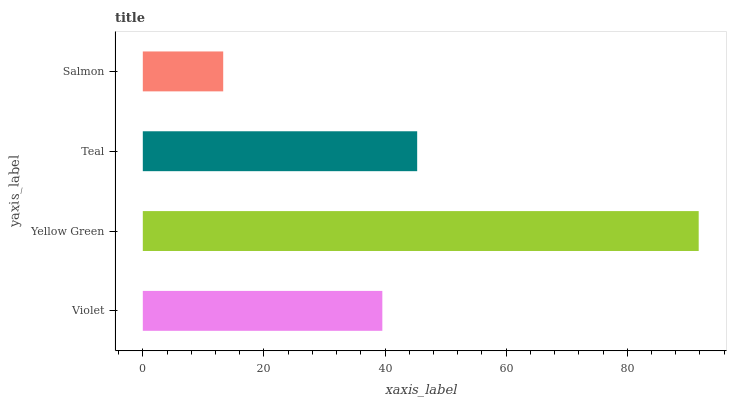Is Salmon the minimum?
Answer yes or no. Yes. Is Yellow Green the maximum?
Answer yes or no. Yes. Is Teal the minimum?
Answer yes or no. No. Is Teal the maximum?
Answer yes or no. No. Is Yellow Green greater than Teal?
Answer yes or no. Yes. Is Teal less than Yellow Green?
Answer yes or no. Yes. Is Teal greater than Yellow Green?
Answer yes or no. No. Is Yellow Green less than Teal?
Answer yes or no. No. Is Teal the high median?
Answer yes or no. Yes. Is Violet the low median?
Answer yes or no. Yes. Is Violet the high median?
Answer yes or no. No. Is Teal the low median?
Answer yes or no. No. 